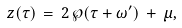Convert formula to latex. <formula><loc_0><loc_0><loc_500><loc_500>z ( \tau ) \, = \, 2 \, \wp ( \tau + \omega ^ { \prime } ) \, + \, \mu ,</formula> 